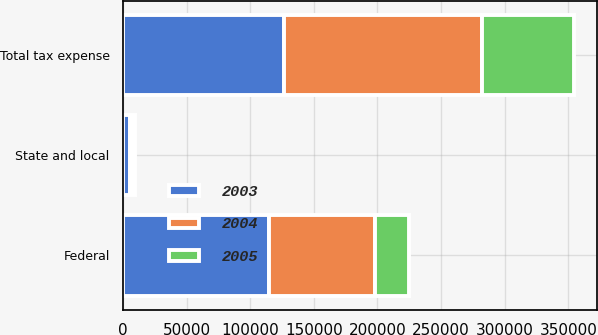Convert chart. <chart><loc_0><loc_0><loc_500><loc_500><stacked_bar_chart><ecel><fcel>Federal<fcel>State and local<fcel>Total tax expense<nl><fcel>2003<fcel>114745<fcel>5809<fcel>126315<nl><fcel>2004<fcel>83428<fcel>2433<fcel>156023<nl><fcel>2005<fcel>26439<fcel>1028<fcel>72270<nl></chart> 